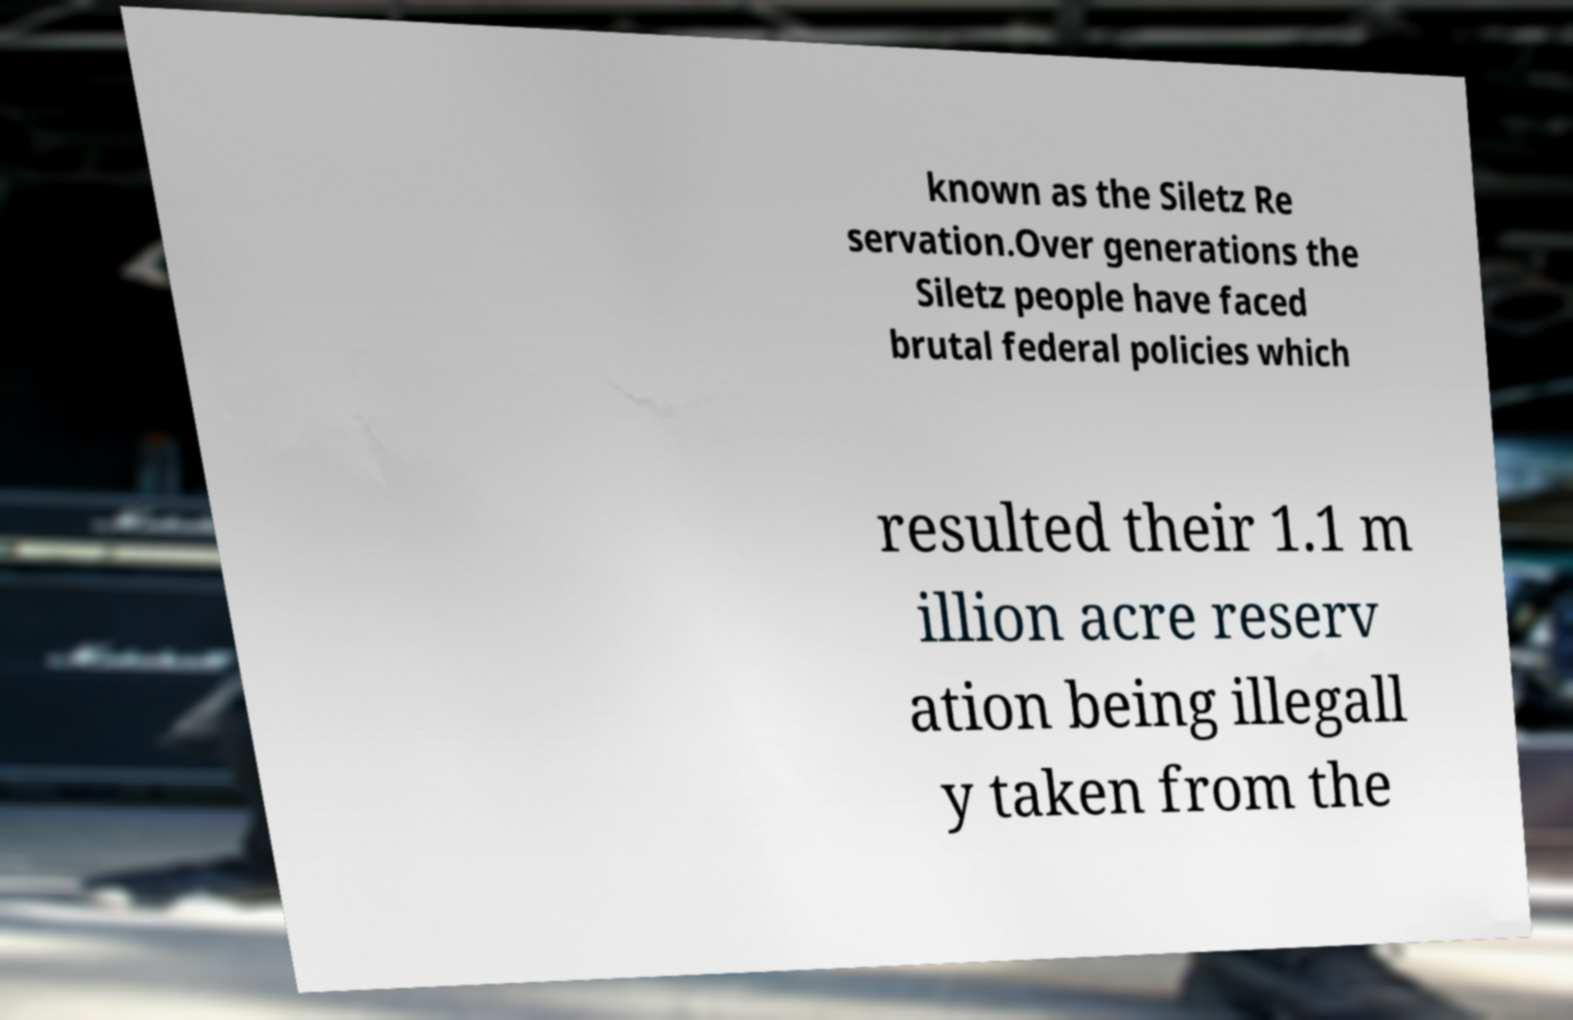Please read and relay the text visible in this image. What does it say? known as the Siletz Re servation.Over generations the Siletz people have faced brutal federal policies which resulted their 1.1 m illion acre reserv ation being illegall y taken from the 